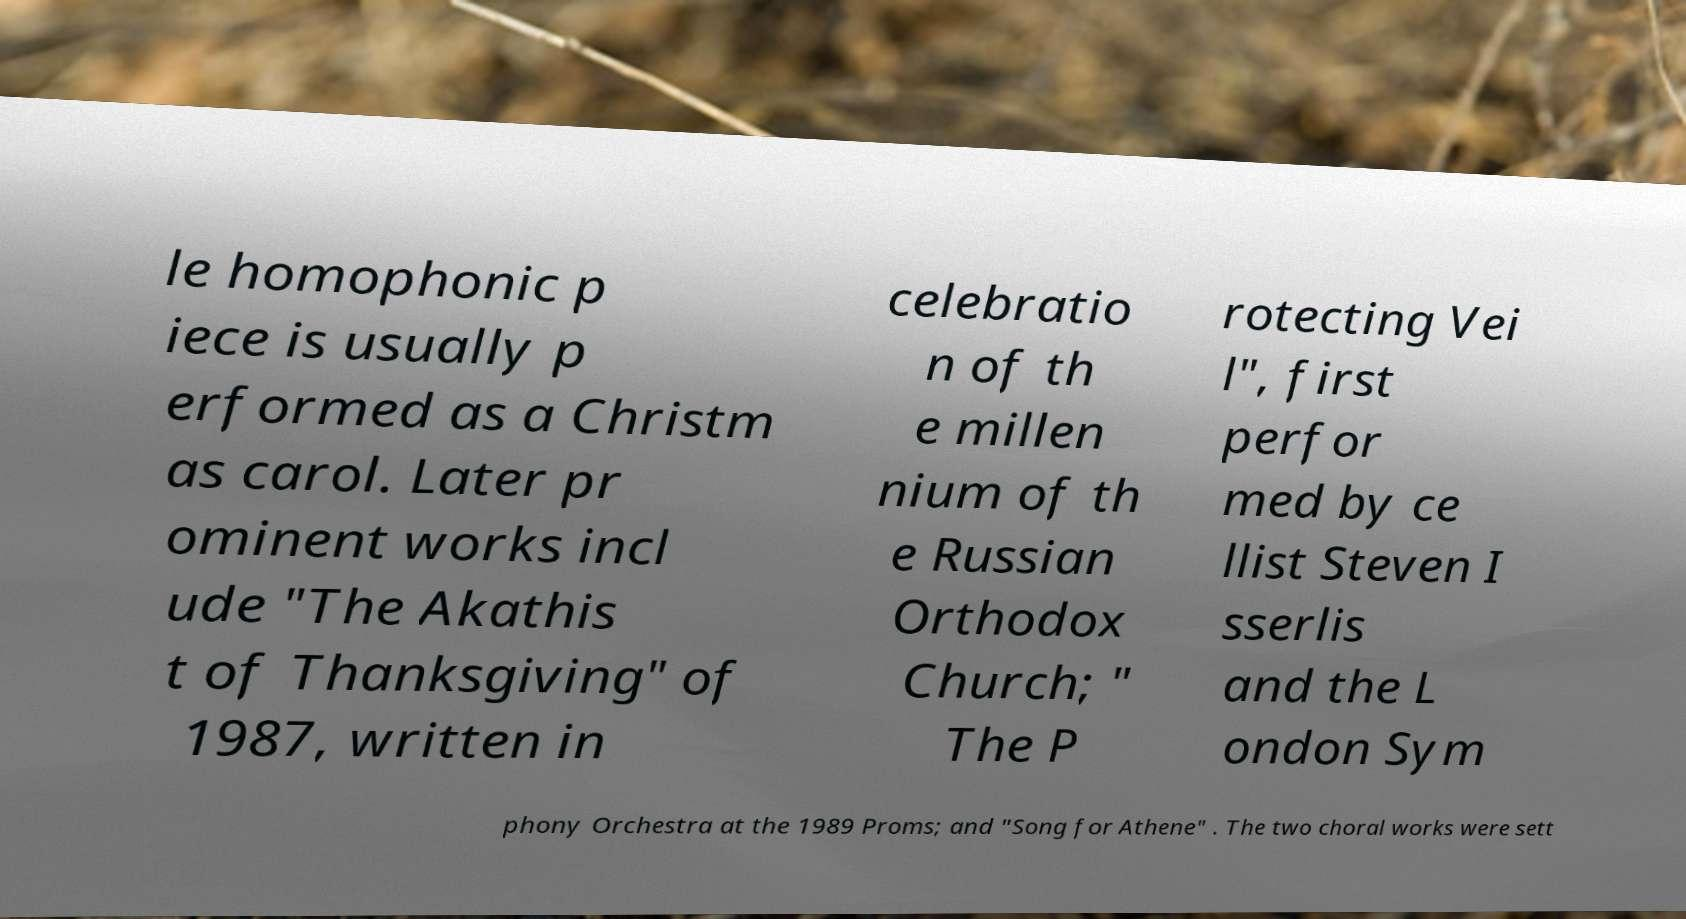Can you read and provide the text displayed in the image?This photo seems to have some interesting text. Can you extract and type it out for me? le homophonic p iece is usually p erformed as a Christm as carol. Later pr ominent works incl ude "The Akathis t of Thanksgiving" of 1987, written in celebratio n of th e millen nium of th e Russian Orthodox Church; " The P rotecting Vei l", first perfor med by ce llist Steven I sserlis and the L ondon Sym phony Orchestra at the 1989 Proms; and "Song for Athene" . The two choral works were sett 